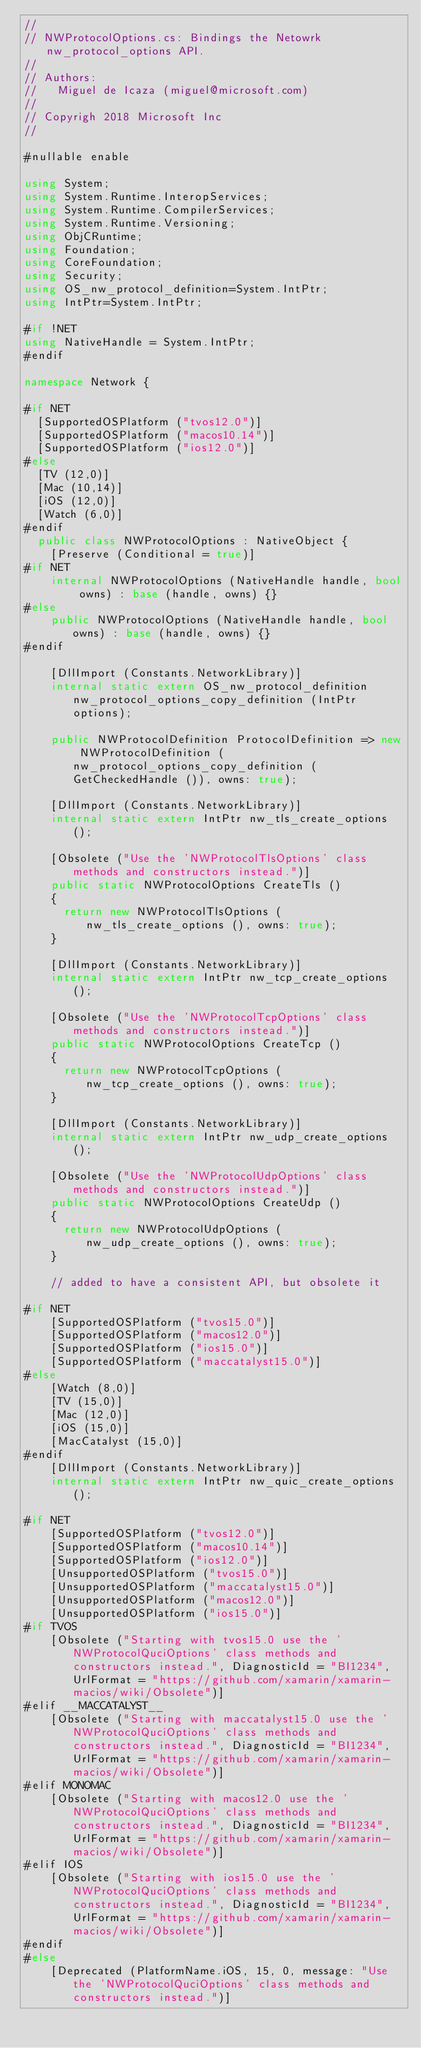<code> <loc_0><loc_0><loc_500><loc_500><_C#_>//
// NWProtocolOptions.cs: Bindings the Netowrk nw_protocol_options API.
//
// Authors:
//   Miguel de Icaza (miguel@microsoft.com)
//
// Copyrigh 2018 Microsoft Inc
//

#nullable enable

using System;
using System.Runtime.InteropServices;
using System.Runtime.CompilerServices;
using System.Runtime.Versioning;
using ObjCRuntime;
using Foundation;
using CoreFoundation;
using Security;
using OS_nw_protocol_definition=System.IntPtr;
using IntPtr=System.IntPtr;

#if !NET
using NativeHandle = System.IntPtr;
#endif

namespace Network {

#if NET
	[SupportedOSPlatform ("tvos12.0")]
	[SupportedOSPlatform ("macos10.14")]
	[SupportedOSPlatform ("ios12.0")]
#else
	[TV (12,0)]
	[Mac (10,14)]
	[iOS (12,0)]
	[Watch (6,0)]
#endif
	public class NWProtocolOptions : NativeObject {
		[Preserve (Conditional = true)]
#if NET
		internal NWProtocolOptions (NativeHandle handle, bool owns) : base (handle, owns) {}
#else
		public NWProtocolOptions (NativeHandle handle, bool owns) : base (handle, owns) {}
#endif

		[DllImport (Constants.NetworkLibrary)]
		internal static extern OS_nw_protocol_definition nw_protocol_options_copy_definition (IntPtr options);

		public NWProtocolDefinition ProtocolDefinition => new NWProtocolDefinition (nw_protocol_options_copy_definition (GetCheckedHandle ()), owns: true);

		[DllImport (Constants.NetworkLibrary)]
		internal static extern IntPtr nw_tls_create_options ();

		[Obsolete ("Use the 'NWProtocolTlsOptions' class methods and constructors instead.")]
		public static NWProtocolOptions CreateTls ()
		{
			return new NWProtocolTlsOptions (nw_tls_create_options (), owns: true);
		}

		[DllImport (Constants.NetworkLibrary)]
		internal static extern IntPtr nw_tcp_create_options ();

		[Obsolete ("Use the 'NWProtocolTcpOptions' class methods and constructors instead.")]
		public static NWProtocolOptions CreateTcp ()
		{
			return new NWProtocolTcpOptions (nw_tcp_create_options (), owns: true);
		}

		[DllImport (Constants.NetworkLibrary)]
		internal static extern IntPtr nw_udp_create_options ();

		[Obsolete ("Use the 'NWProtocolUdpOptions' class methods and constructors instead.")]
		public static NWProtocolOptions CreateUdp ()
		{
			return new NWProtocolUdpOptions (nw_udp_create_options (), owns: true);
		}

		// added to have a consistent API, but obsolete it

#if NET
		[SupportedOSPlatform ("tvos15.0")]
		[SupportedOSPlatform ("macos12.0")]
		[SupportedOSPlatform ("ios15.0")]
		[SupportedOSPlatform ("maccatalyst15.0")]
#else
		[Watch (8,0)]
		[TV (15,0)]
		[Mac (12,0)]
		[iOS (15,0)]
		[MacCatalyst (15,0)]
#endif
		[DllImport (Constants.NetworkLibrary)]
		internal static extern IntPtr nw_quic_create_options ();

#if NET
		[SupportedOSPlatform ("tvos12.0")]
		[SupportedOSPlatform ("macos10.14")]
		[SupportedOSPlatform ("ios12.0")]
		[UnsupportedOSPlatform ("tvos15.0")]
		[UnsupportedOSPlatform ("maccatalyst15.0")]
		[UnsupportedOSPlatform ("macos12.0")]
		[UnsupportedOSPlatform ("ios15.0")]
#if TVOS
		[Obsolete ("Starting with tvos15.0 use the 'NWProtocolQuciOptions' class methods and constructors instead.", DiagnosticId = "BI1234", UrlFormat = "https://github.com/xamarin/xamarin-macios/wiki/Obsolete")]
#elif __MACCATALYST__
		[Obsolete ("Starting with maccatalyst15.0 use the 'NWProtocolQuciOptions' class methods and constructors instead.", DiagnosticId = "BI1234", UrlFormat = "https://github.com/xamarin/xamarin-macios/wiki/Obsolete")]
#elif MONOMAC
		[Obsolete ("Starting with macos12.0 use the 'NWProtocolQuciOptions' class methods and constructors instead.", DiagnosticId = "BI1234", UrlFormat = "https://github.com/xamarin/xamarin-macios/wiki/Obsolete")]
#elif IOS
		[Obsolete ("Starting with ios15.0 use the 'NWProtocolQuciOptions' class methods and constructors instead.", DiagnosticId = "BI1234", UrlFormat = "https://github.com/xamarin/xamarin-macios/wiki/Obsolete")]
#endif
#else
		[Deprecated (PlatformName.iOS, 15, 0, message: "Use the 'NWProtocolQuciOptions' class methods and constructors instead.")]</code> 